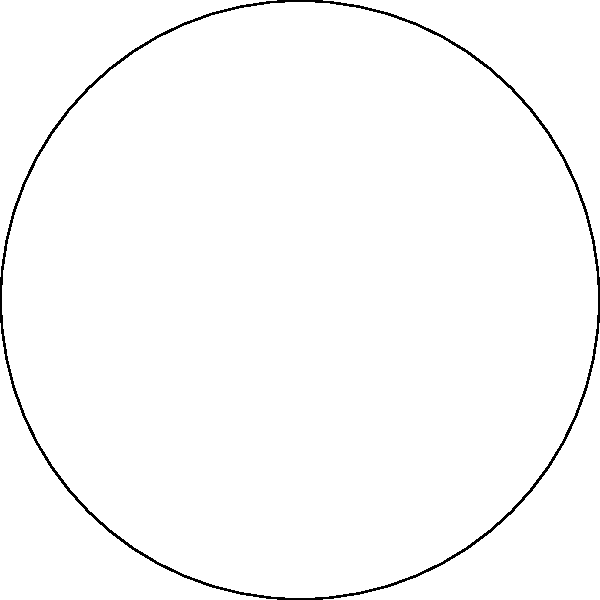In your circular garden with a radius of 10 meters, you want to arrange 6 raised garden beds around the perimeter. If you place the center of each bed on the circle's circumference, what is the angle (in degrees) between the radii connecting adjacent bed centers to maximize space efficiency? To maximize space efficiency in this circular garden design, we need to distribute the 6 raised garden beds evenly around the circle. Here's how we can calculate the angle:

1. A full circle contains 360 degrees or $2\pi$ radians.

2. We need to divide the circle into 6 equal parts, one for each garden bed.

3. The angle between adjacent beds (in degrees) can be calculated as:
   $$\text{Angle} = \frac{360^\circ}{\text{Number of beds}}$$

4. Substituting our values:
   $$\text{Angle} = \frac{360^\circ}{6} = 60^\circ$$

5. We can verify this result by considering that 6 angles of 60° each will sum to 360°, forming a complete circle:
   $$6 \times 60^\circ = 360^\circ$$

This arrangement ensures that the garden beds are evenly spaced around the circle, maximizing the use of the available space and creating a symmetrical design.
Answer: 60° 